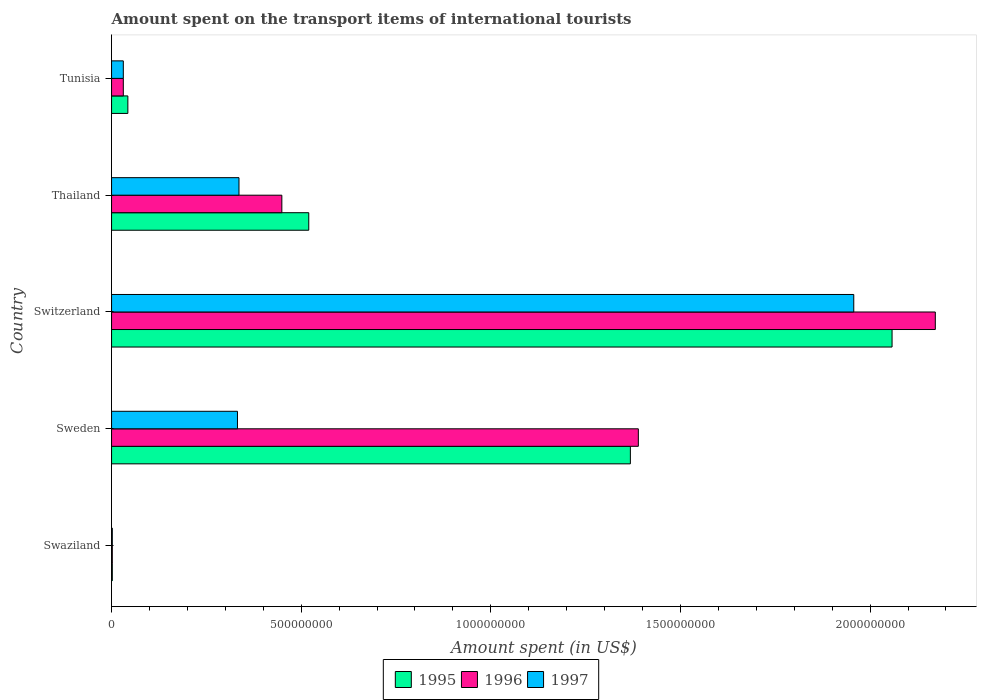Are the number of bars on each tick of the Y-axis equal?
Give a very brief answer. Yes. What is the label of the 5th group of bars from the top?
Make the answer very short. Swaziland. What is the amount spent on the transport items of international tourists in 1995 in Tunisia?
Your answer should be compact. 4.30e+07. Across all countries, what is the maximum amount spent on the transport items of international tourists in 1996?
Offer a very short reply. 2.17e+09. In which country was the amount spent on the transport items of international tourists in 1995 maximum?
Your response must be concise. Switzerland. In which country was the amount spent on the transport items of international tourists in 1995 minimum?
Your answer should be very brief. Swaziland. What is the total amount spent on the transport items of international tourists in 1997 in the graph?
Your answer should be compact. 2.66e+09. What is the difference between the amount spent on the transport items of international tourists in 1996 in Sweden and that in Switzerland?
Offer a very short reply. -7.83e+08. What is the difference between the amount spent on the transport items of international tourists in 1996 in Switzerland and the amount spent on the transport items of international tourists in 1997 in Sweden?
Ensure brevity in your answer.  1.84e+09. What is the average amount spent on the transport items of international tourists in 1995 per country?
Ensure brevity in your answer.  7.98e+08. What is the difference between the amount spent on the transport items of international tourists in 1996 and amount spent on the transport items of international tourists in 1997 in Switzerland?
Your response must be concise. 2.15e+08. What is the ratio of the amount spent on the transport items of international tourists in 1995 in Sweden to that in Thailand?
Offer a very short reply. 2.63. Is the amount spent on the transport items of international tourists in 1997 in Swaziland less than that in Sweden?
Make the answer very short. Yes. Is the difference between the amount spent on the transport items of international tourists in 1996 in Sweden and Tunisia greater than the difference between the amount spent on the transport items of international tourists in 1997 in Sweden and Tunisia?
Give a very brief answer. Yes. What is the difference between the highest and the second highest amount spent on the transport items of international tourists in 1997?
Provide a short and direct response. 1.62e+09. What is the difference between the highest and the lowest amount spent on the transport items of international tourists in 1995?
Give a very brief answer. 2.06e+09. In how many countries, is the amount spent on the transport items of international tourists in 1996 greater than the average amount spent on the transport items of international tourists in 1996 taken over all countries?
Your answer should be very brief. 2. What does the 2nd bar from the bottom in Sweden represents?
Give a very brief answer. 1996. Is it the case that in every country, the sum of the amount spent on the transport items of international tourists in 1997 and amount spent on the transport items of international tourists in 1996 is greater than the amount spent on the transport items of international tourists in 1995?
Ensure brevity in your answer.  Yes. How many bars are there?
Keep it short and to the point. 15. Where does the legend appear in the graph?
Provide a succinct answer. Bottom center. How many legend labels are there?
Your response must be concise. 3. How are the legend labels stacked?
Offer a very short reply. Horizontal. What is the title of the graph?
Your response must be concise. Amount spent on the transport items of international tourists. Does "2007" appear as one of the legend labels in the graph?
Keep it short and to the point. No. What is the label or title of the X-axis?
Provide a short and direct response. Amount spent (in US$). What is the Amount spent (in US$) in 1995 in Swaziland?
Offer a very short reply. 2.00e+06. What is the Amount spent (in US$) in 1996 in Swaziland?
Give a very brief answer. 2.00e+06. What is the Amount spent (in US$) in 1997 in Swaziland?
Keep it short and to the point. 2.00e+06. What is the Amount spent (in US$) of 1995 in Sweden?
Ensure brevity in your answer.  1.37e+09. What is the Amount spent (in US$) of 1996 in Sweden?
Offer a very short reply. 1.39e+09. What is the Amount spent (in US$) in 1997 in Sweden?
Your answer should be compact. 3.32e+08. What is the Amount spent (in US$) in 1995 in Switzerland?
Your response must be concise. 2.06e+09. What is the Amount spent (in US$) of 1996 in Switzerland?
Your response must be concise. 2.17e+09. What is the Amount spent (in US$) of 1997 in Switzerland?
Keep it short and to the point. 1.96e+09. What is the Amount spent (in US$) of 1995 in Thailand?
Make the answer very short. 5.20e+08. What is the Amount spent (in US$) of 1996 in Thailand?
Provide a short and direct response. 4.49e+08. What is the Amount spent (in US$) of 1997 in Thailand?
Your response must be concise. 3.36e+08. What is the Amount spent (in US$) in 1995 in Tunisia?
Keep it short and to the point. 4.30e+07. What is the Amount spent (in US$) in 1996 in Tunisia?
Your answer should be very brief. 3.10e+07. What is the Amount spent (in US$) in 1997 in Tunisia?
Your response must be concise. 3.10e+07. Across all countries, what is the maximum Amount spent (in US$) in 1995?
Ensure brevity in your answer.  2.06e+09. Across all countries, what is the maximum Amount spent (in US$) in 1996?
Keep it short and to the point. 2.17e+09. Across all countries, what is the maximum Amount spent (in US$) in 1997?
Your answer should be very brief. 1.96e+09. Across all countries, what is the minimum Amount spent (in US$) in 1996?
Provide a short and direct response. 2.00e+06. What is the total Amount spent (in US$) in 1995 in the graph?
Your answer should be compact. 3.99e+09. What is the total Amount spent (in US$) in 1996 in the graph?
Offer a very short reply. 4.04e+09. What is the total Amount spent (in US$) in 1997 in the graph?
Offer a very short reply. 2.66e+09. What is the difference between the Amount spent (in US$) in 1995 in Swaziland and that in Sweden?
Provide a succinct answer. -1.37e+09. What is the difference between the Amount spent (in US$) in 1996 in Swaziland and that in Sweden?
Give a very brief answer. -1.39e+09. What is the difference between the Amount spent (in US$) of 1997 in Swaziland and that in Sweden?
Offer a very short reply. -3.30e+08. What is the difference between the Amount spent (in US$) in 1995 in Swaziland and that in Switzerland?
Offer a very short reply. -2.06e+09. What is the difference between the Amount spent (in US$) of 1996 in Swaziland and that in Switzerland?
Provide a succinct answer. -2.17e+09. What is the difference between the Amount spent (in US$) of 1997 in Swaziland and that in Switzerland?
Provide a succinct answer. -1.96e+09. What is the difference between the Amount spent (in US$) in 1995 in Swaziland and that in Thailand?
Provide a short and direct response. -5.18e+08. What is the difference between the Amount spent (in US$) in 1996 in Swaziland and that in Thailand?
Offer a very short reply. -4.47e+08. What is the difference between the Amount spent (in US$) in 1997 in Swaziland and that in Thailand?
Your answer should be very brief. -3.34e+08. What is the difference between the Amount spent (in US$) in 1995 in Swaziland and that in Tunisia?
Offer a terse response. -4.10e+07. What is the difference between the Amount spent (in US$) of 1996 in Swaziland and that in Tunisia?
Keep it short and to the point. -2.90e+07. What is the difference between the Amount spent (in US$) of 1997 in Swaziland and that in Tunisia?
Provide a short and direct response. -2.90e+07. What is the difference between the Amount spent (in US$) in 1995 in Sweden and that in Switzerland?
Your answer should be very brief. -6.90e+08. What is the difference between the Amount spent (in US$) of 1996 in Sweden and that in Switzerland?
Provide a succinct answer. -7.83e+08. What is the difference between the Amount spent (in US$) of 1997 in Sweden and that in Switzerland?
Your answer should be very brief. -1.62e+09. What is the difference between the Amount spent (in US$) in 1995 in Sweden and that in Thailand?
Provide a succinct answer. 8.48e+08. What is the difference between the Amount spent (in US$) of 1996 in Sweden and that in Thailand?
Provide a short and direct response. 9.40e+08. What is the difference between the Amount spent (in US$) in 1995 in Sweden and that in Tunisia?
Make the answer very short. 1.32e+09. What is the difference between the Amount spent (in US$) in 1996 in Sweden and that in Tunisia?
Ensure brevity in your answer.  1.36e+09. What is the difference between the Amount spent (in US$) in 1997 in Sweden and that in Tunisia?
Provide a short and direct response. 3.01e+08. What is the difference between the Amount spent (in US$) in 1995 in Switzerland and that in Thailand?
Your response must be concise. 1.54e+09. What is the difference between the Amount spent (in US$) in 1996 in Switzerland and that in Thailand?
Provide a succinct answer. 1.72e+09. What is the difference between the Amount spent (in US$) in 1997 in Switzerland and that in Thailand?
Your response must be concise. 1.62e+09. What is the difference between the Amount spent (in US$) of 1995 in Switzerland and that in Tunisia?
Your answer should be very brief. 2.02e+09. What is the difference between the Amount spent (in US$) of 1996 in Switzerland and that in Tunisia?
Make the answer very short. 2.14e+09. What is the difference between the Amount spent (in US$) in 1997 in Switzerland and that in Tunisia?
Ensure brevity in your answer.  1.93e+09. What is the difference between the Amount spent (in US$) in 1995 in Thailand and that in Tunisia?
Your answer should be very brief. 4.77e+08. What is the difference between the Amount spent (in US$) in 1996 in Thailand and that in Tunisia?
Provide a short and direct response. 4.18e+08. What is the difference between the Amount spent (in US$) of 1997 in Thailand and that in Tunisia?
Offer a very short reply. 3.05e+08. What is the difference between the Amount spent (in US$) of 1995 in Swaziland and the Amount spent (in US$) of 1996 in Sweden?
Provide a succinct answer. -1.39e+09. What is the difference between the Amount spent (in US$) in 1995 in Swaziland and the Amount spent (in US$) in 1997 in Sweden?
Offer a terse response. -3.30e+08. What is the difference between the Amount spent (in US$) in 1996 in Swaziland and the Amount spent (in US$) in 1997 in Sweden?
Provide a short and direct response. -3.30e+08. What is the difference between the Amount spent (in US$) in 1995 in Swaziland and the Amount spent (in US$) in 1996 in Switzerland?
Your response must be concise. -2.17e+09. What is the difference between the Amount spent (in US$) in 1995 in Swaziland and the Amount spent (in US$) in 1997 in Switzerland?
Make the answer very short. -1.96e+09. What is the difference between the Amount spent (in US$) in 1996 in Swaziland and the Amount spent (in US$) in 1997 in Switzerland?
Your answer should be very brief. -1.96e+09. What is the difference between the Amount spent (in US$) in 1995 in Swaziland and the Amount spent (in US$) in 1996 in Thailand?
Your answer should be compact. -4.47e+08. What is the difference between the Amount spent (in US$) of 1995 in Swaziland and the Amount spent (in US$) of 1997 in Thailand?
Offer a terse response. -3.34e+08. What is the difference between the Amount spent (in US$) in 1996 in Swaziland and the Amount spent (in US$) in 1997 in Thailand?
Offer a very short reply. -3.34e+08. What is the difference between the Amount spent (in US$) in 1995 in Swaziland and the Amount spent (in US$) in 1996 in Tunisia?
Your response must be concise. -2.90e+07. What is the difference between the Amount spent (in US$) of 1995 in Swaziland and the Amount spent (in US$) of 1997 in Tunisia?
Offer a terse response. -2.90e+07. What is the difference between the Amount spent (in US$) of 1996 in Swaziland and the Amount spent (in US$) of 1997 in Tunisia?
Offer a terse response. -2.90e+07. What is the difference between the Amount spent (in US$) of 1995 in Sweden and the Amount spent (in US$) of 1996 in Switzerland?
Your answer should be very brief. -8.04e+08. What is the difference between the Amount spent (in US$) in 1995 in Sweden and the Amount spent (in US$) in 1997 in Switzerland?
Offer a terse response. -5.89e+08. What is the difference between the Amount spent (in US$) of 1996 in Sweden and the Amount spent (in US$) of 1997 in Switzerland?
Give a very brief answer. -5.68e+08. What is the difference between the Amount spent (in US$) in 1995 in Sweden and the Amount spent (in US$) in 1996 in Thailand?
Offer a very short reply. 9.19e+08. What is the difference between the Amount spent (in US$) in 1995 in Sweden and the Amount spent (in US$) in 1997 in Thailand?
Provide a succinct answer. 1.03e+09. What is the difference between the Amount spent (in US$) of 1996 in Sweden and the Amount spent (in US$) of 1997 in Thailand?
Your answer should be very brief. 1.05e+09. What is the difference between the Amount spent (in US$) in 1995 in Sweden and the Amount spent (in US$) in 1996 in Tunisia?
Provide a short and direct response. 1.34e+09. What is the difference between the Amount spent (in US$) in 1995 in Sweden and the Amount spent (in US$) in 1997 in Tunisia?
Your answer should be very brief. 1.34e+09. What is the difference between the Amount spent (in US$) in 1996 in Sweden and the Amount spent (in US$) in 1997 in Tunisia?
Provide a short and direct response. 1.36e+09. What is the difference between the Amount spent (in US$) in 1995 in Switzerland and the Amount spent (in US$) in 1996 in Thailand?
Provide a short and direct response. 1.61e+09. What is the difference between the Amount spent (in US$) of 1995 in Switzerland and the Amount spent (in US$) of 1997 in Thailand?
Provide a short and direct response. 1.72e+09. What is the difference between the Amount spent (in US$) of 1996 in Switzerland and the Amount spent (in US$) of 1997 in Thailand?
Offer a terse response. 1.84e+09. What is the difference between the Amount spent (in US$) of 1995 in Switzerland and the Amount spent (in US$) of 1996 in Tunisia?
Your response must be concise. 2.03e+09. What is the difference between the Amount spent (in US$) in 1995 in Switzerland and the Amount spent (in US$) in 1997 in Tunisia?
Offer a very short reply. 2.03e+09. What is the difference between the Amount spent (in US$) of 1996 in Switzerland and the Amount spent (in US$) of 1997 in Tunisia?
Your answer should be compact. 2.14e+09. What is the difference between the Amount spent (in US$) of 1995 in Thailand and the Amount spent (in US$) of 1996 in Tunisia?
Your answer should be compact. 4.89e+08. What is the difference between the Amount spent (in US$) of 1995 in Thailand and the Amount spent (in US$) of 1997 in Tunisia?
Your response must be concise. 4.89e+08. What is the difference between the Amount spent (in US$) in 1996 in Thailand and the Amount spent (in US$) in 1997 in Tunisia?
Provide a short and direct response. 4.18e+08. What is the average Amount spent (in US$) in 1995 per country?
Keep it short and to the point. 7.98e+08. What is the average Amount spent (in US$) in 1996 per country?
Keep it short and to the point. 8.09e+08. What is the average Amount spent (in US$) of 1997 per country?
Keep it short and to the point. 5.32e+08. What is the difference between the Amount spent (in US$) of 1996 and Amount spent (in US$) of 1997 in Swaziland?
Your answer should be compact. 0. What is the difference between the Amount spent (in US$) in 1995 and Amount spent (in US$) in 1996 in Sweden?
Keep it short and to the point. -2.10e+07. What is the difference between the Amount spent (in US$) of 1995 and Amount spent (in US$) of 1997 in Sweden?
Give a very brief answer. 1.04e+09. What is the difference between the Amount spent (in US$) of 1996 and Amount spent (in US$) of 1997 in Sweden?
Make the answer very short. 1.06e+09. What is the difference between the Amount spent (in US$) in 1995 and Amount spent (in US$) in 1996 in Switzerland?
Your answer should be very brief. -1.14e+08. What is the difference between the Amount spent (in US$) of 1995 and Amount spent (in US$) of 1997 in Switzerland?
Offer a terse response. 1.01e+08. What is the difference between the Amount spent (in US$) in 1996 and Amount spent (in US$) in 1997 in Switzerland?
Provide a succinct answer. 2.15e+08. What is the difference between the Amount spent (in US$) in 1995 and Amount spent (in US$) in 1996 in Thailand?
Your answer should be very brief. 7.10e+07. What is the difference between the Amount spent (in US$) in 1995 and Amount spent (in US$) in 1997 in Thailand?
Provide a succinct answer. 1.84e+08. What is the difference between the Amount spent (in US$) in 1996 and Amount spent (in US$) in 1997 in Thailand?
Ensure brevity in your answer.  1.13e+08. What is the difference between the Amount spent (in US$) in 1995 and Amount spent (in US$) in 1997 in Tunisia?
Give a very brief answer. 1.20e+07. What is the ratio of the Amount spent (in US$) of 1995 in Swaziland to that in Sweden?
Offer a terse response. 0. What is the ratio of the Amount spent (in US$) in 1996 in Swaziland to that in Sweden?
Provide a succinct answer. 0. What is the ratio of the Amount spent (in US$) in 1997 in Swaziland to that in Sweden?
Your response must be concise. 0.01. What is the ratio of the Amount spent (in US$) of 1996 in Swaziland to that in Switzerland?
Provide a succinct answer. 0. What is the ratio of the Amount spent (in US$) in 1997 in Swaziland to that in Switzerland?
Give a very brief answer. 0. What is the ratio of the Amount spent (in US$) in 1995 in Swaziland to that in Thailand?
Provide a succinct answer. 0. What is the ratio of the Amount spent (in US$) of 1996 in Swaziland to that in Thailand?
Provide a short and direct response. 0. What is the ratio of the Amount spent (in US$) in 1997 in Swaziland to that in Thailand?
Offer a terse response. 0.01. What is the ratio of the Amount spent (in US$) of 1995 in Swaziland to that in Tunisia?
Ensure brevity in your answer.  0.05. What is the ratio of the Amount spent (in US$) in 1996 in Swaziland to that in Tunisia?
Offer a very short reply. 0.06. What is the ratio of the Amount spent (in US$) in 1997 in Swaziland to that in Tunisia?
Provide a short and direct response. 0.06. What is the ratio of the Amount spent (in US$) in 1995 in Sweden to that in Switzerland?
Your answer should be compact. 0.66. What is the ratio of the Amount spent (in US$) of 1996 in Sweden to that in Switzerland?
Provide a short and direct response. 0.64. What is the ratio of the Amount spent (in US$) in 1997 in Sweden to that in Switzerland?
Provide a short and direct response. 0.17. What is the ratio of the Amount spent (in US$) of 1995 in Sweden to that in Thailand?
Make the answer very short. 2.63. What is the ratio of the Amount spent (in US$) in 1996 in Sweden to that in Thailand?
Your answer should be compact. 3.09. What is the ratio of the Amount spent (in US$) in 1995 in Sweden to that in Tunisia?
Make the answer very short. 31.81. What is the ratio of the Amount spent (in US$) of 1996 in Sweden to that in Tunisia?
Offer a terse response. 44.81. What is the ratio of the Amount spent (in US$) of 1997 in Sweden to that in Tunisia?
Give a very brief answer. 10.71. What is the ratio of the Amount spent (in US$) in 1995 in Switzerland to that in Thailand?
Keep it short and to the point. 3.96. What is the ratio of the Amount spent (in US$) in 1996 in Switzerland to that in Thailand?
Make the answer very short. 4.84. What is the ratio of the Amount spent (in US$) in 1997 in Switzerland to that in Thailand?
Your response must be concise. 5.82. What is the ratio of the Amount spent (in US$) in 1995 in Switzerland to that in Tunisia?
Ensure brevity in your answer.  47.86. What is the ratio of the Amount spent (in US$) of 1996 in Switzerland to that in Tunisia?
Provide a short and direct response. 70.06. What is the ratio of the Amount spent (in US$) of 1997 in Switzerland to that in Tunisia?
Make the answer very short. 63.13. What is the ratio of the Amount spent (in US$) of 1995 in Thailand to that in Tunisia?
Your answer should be compact. 12.09. What is the ratio of the Amount spent (in US$) of 1996 in Thailand to that in Tunisia?
Keep it short and to the point. 14.48. What is the ratio of the Amount spent (in US$) of 1997 in Thailand to that in Tunisia?
Offer a very short reply. 10.84. What is the difference between the highest and the second highest Amount spent (in US$) in 1995?
Offer a terse response. 6.90e+08. What is the difference between the highest and the second highest Amount spent (in US$) of 1996?
Your answer should be very brief. 7.83e+08. What is the difference between the highest and the second highest Amount spent (in US$) in 1997?
Give a very brief answer. 1.62e+09. What is the difference between the highest and the lowest Amount spent (in US$) in 1995?
Your response must be concise. 2.06e+09. What is the difference between the highest and the lowest Amount spent (in US$) of 1996?
Offer a very short reply. 2.17e+09. What is the difference between the highest and the lowest Amount spent (in US$) of 1997?
Your answer should be very brief. 1.96e+09. 